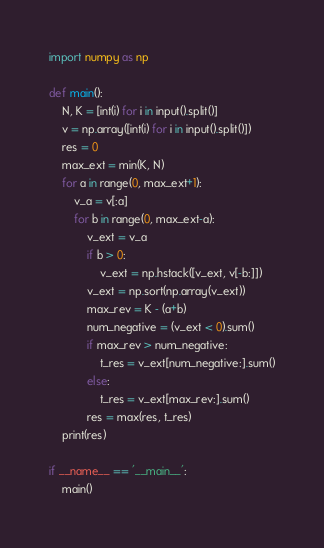<code> <loc_0><loc_0><loc_500><loc_500><_Python_>import numpy as np

def main():
    N, K = [int(i) for i in input().split()]
    v = np.array([int(i) for i in input().split()])
    res = 0
    max_ext = min(K, N)
    for a in range(0, max_ext+1):
        v_a = v[:a] 
        for b in range(0, max_ext-a):
            v_ext = v_a
            if b > 0:
                v_ext = np.hstack([v_ext, v[-b:]])
            v_ext = np.sort(np.array(v_ext))
            max_rev = K - (a+b)
            num_negative = (v_ext < 0).sum()
            if max_rev > num_negative:
                t_res = v_ext[num_negative:].sum()
            else:
                t_res = v_ext[max_rev:].sum()
            res = max(res, t_res) 
    print(res)

if __name__ == '__main__':
    main()

</code> 